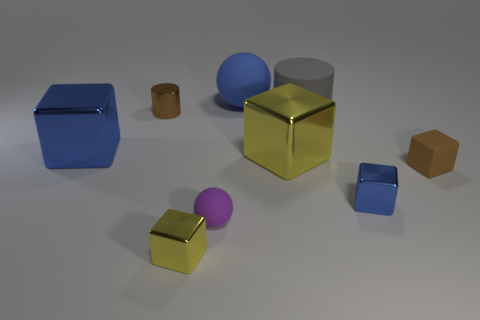What number of blue things are both on the right side of the large blue cube and to the left of the large gray cylinder?
Make the answer very short. 1. What is the material of the yellow thing in front of the tiny brown rubber thing?
Provide a short and direct response. Metal. What size is the brown object that is made of the same material as the big gray cylinder?
Make the answer very short. Small. There is a yellow metallic block to the right of the purple matte ball; is it the same size as the rubber thing in front of the brown matte object?
Offer a terse response. No. There is a blue thing that is the same size as the purple sphere; what is its material?
Your answer should be compact. Metal. What is the material of the small cube that is both right of the big gray cylinder and to the left of the small brown matte object?
Your response must be concise. Metal. Is there a large block?
Offer a very short reply. Yes. There is a tiny matte cube; does it have the same color as the matte object in front of the rubber cube?
Provide a succinct answer. No. There is a tiny block that is the same color as the metallic cylinder; what is its material?
Provide a short and direct response. Rubber. Is there anything else that has the same shape as the brown matte thing?
Make the answer very short. Yes. 